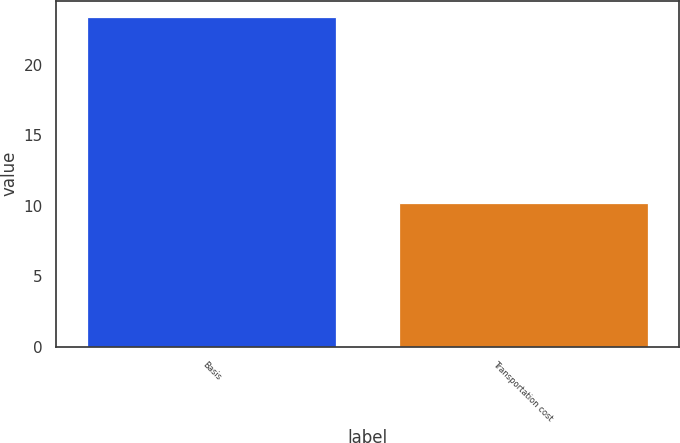Convert chart to OTSL. <chart><loc_0><loc_0><loc_500><loc_500><bar_chart><fcel>Basis<fcel>Transportation cost<nl><fcel>23.4<fcel>10.2<nl></chart> 